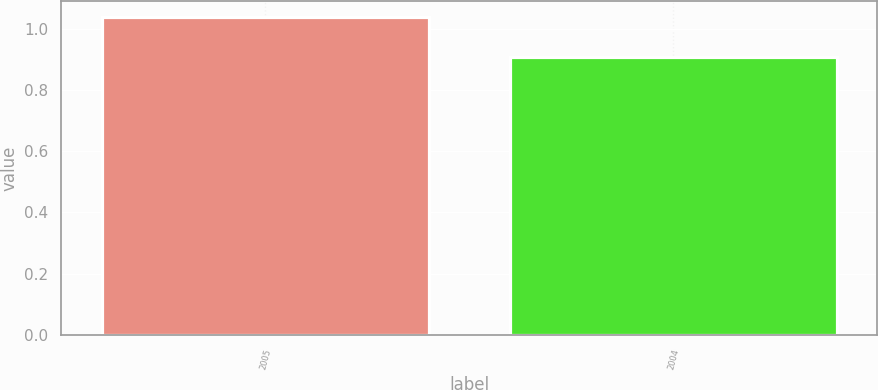<chart> <loc_0><loc_0><loc_500><loc_500><bar_chart><fcel>2005<fcel>2004<nl><fcel>1.04<fcel>0.91<nl></chart> 